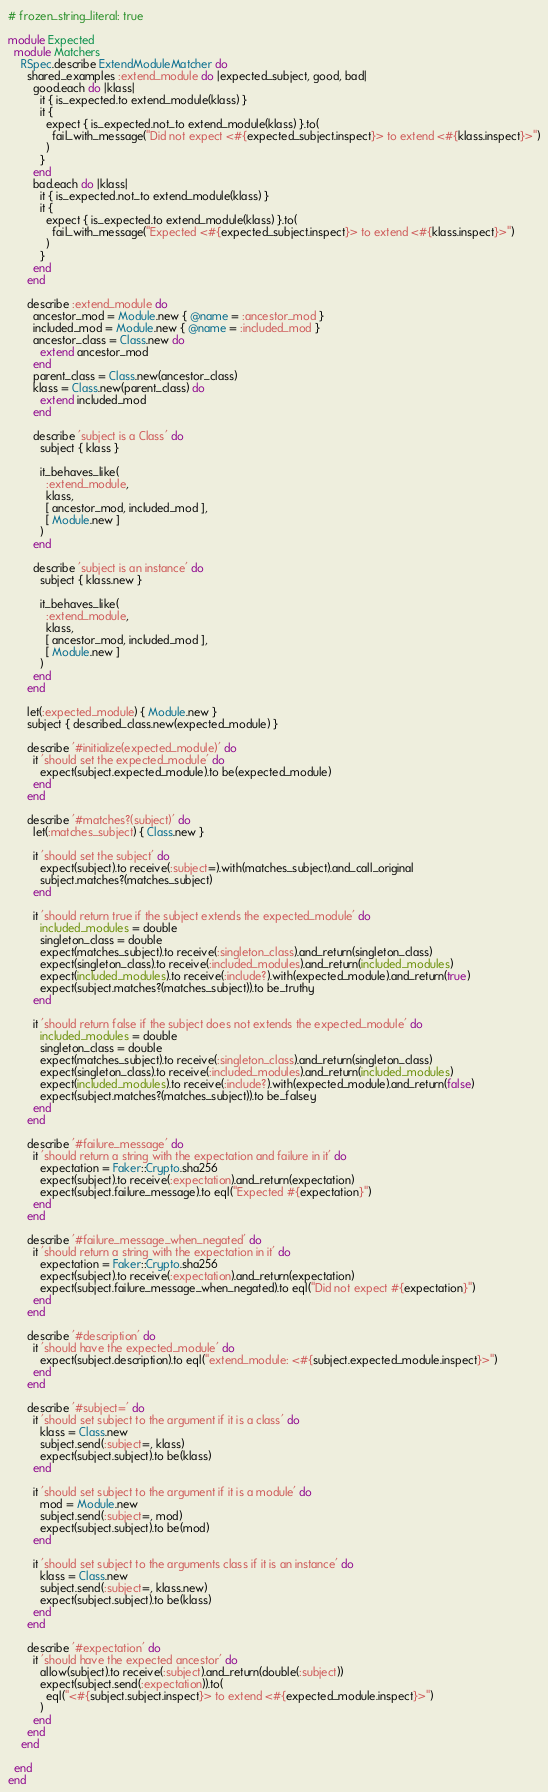<code> <loc_0><loc_0><loc_500><loc_500><_Ruby_># frozen_string_literal: true

module Expected
  module Matchers
    RSpec.describe ExtendModuleMatcher do
      shared_examples :extend_module do |expected_subject, good, bad|
        good.each do |klass|
          it { is_expected.to extend_module(klass) }
          it {
            expect { is_expected.not_to extend_module(klass) }.to(
              fail_with_message("Did not expect <#{expected_subject.inspect}> to extend <#{klass.inspect}>")
            )
          }
        end
        bad.each do |klass|
          it { is_expected.not_to extend_module(klass) }
          it {
            expect { is_expected.to extend_module(klass) }.to(
              fail_with_message("Expected <#{expected_subject.inspect}> to extend <#{klass.inspect}>")
            )
          }
        end
      end

      describe :extend_module do
        ancestor_mod = Module.new { @name = :ancestor_mod }
        included_mod = Module.new { @name = :included_mod }
        ancestor_class = Class.new do
          extend ancestor_mod
        end
        parent_class = Class.new(ancestor_class)
        klass = Class.new(parent_class) do
          extend included_mod
        end

        describe 'subject is a Class' do
          subject { klass }

          it_behaves_like(
            :extend_module,
            klass,
            [ ancestor_mod, included_mod ],
            [ Module.new ]
          )
        end

        describe 'subject is an instance' do
          subject { klass.new }

          it_behaves_like(
            :extend_module,
            klass,
            [ ancestor_mod, included_mod ],
            [ Module.new ]
          )
        end
      end

      let(:expected_module) { Module.new }
      subject { described_class.new(expected_module) }

      describe '#initialize(expected_module)' do
        it 'should set the expected_module' do
          expect(subject.expected_module).to be(expected_module)
        end
      end

      describe '#matches?(subject)' do
        let(:matches_subject) { Class.new }

        it 'should set the subject' do
          expect(subject).to receive(:subject=).with(matches_subject).and_call_original
          subject.matches?(matches_subject)
        end

        it 'should return true if the subject extends the expected_module' do
          included_modules = double
          singleton_class = double
          expect(matches_subject).to receive(:singleton_class).and_return(singleton_class)
          expect(singleton_class).to receive(:included_modules).and_return(included_modules)
          expect(included_modules).to receive(:include?).with(expected_module).and_return(true)
          expect(subject.matches?(matches_subject)).to be_truthy
        end

        it 'should return false if the subject does not extends the expected_module' do
          included_modules = double
          singleton_class = double
          expect(matches_subject).to receive(:singleton_class).and_return(singleton_class)
          expect(singleton_class).to receive(:included_modules).and_return(included_modules)
          expect(included_modules).to receive(:include?).with(expected_module).and_return(false)
          expect(subject.matches?(matches_subject)).to be_falsey
        end
      end

      describe '#failure_message' do
        it 'should return a string with the expectation and failure in it' do
          expectation = Faker::Crypto.sha256
          expect(subject).to receive(:expectation).and_return(expectation)
          expect(subject.failure_message).to eql("Expected #{expectation}")
        end
      end

      describe '#failure_message_when_negated' do
        it 'should return a string with the expectation in it' do
          expectation = Faker::Crypto.sha256
          expect(subject).to receive(:expectation).and_return(expectation)
          expect(subject.failure_message_when_negated).to eql("Did not expect #{expectation}")
        end
      end

      describe '#description' do
        it 'should have the expected_module' do
          expect(subject.description).to eql("extend_module: <#{subject.expected_module.inspect}>")
        end
      end

      describe '#subject=' do
        it 'should set subject to the argument if it is a class' do
          klass = Class.new
          subject.send(:subject=, klass)
          expect(subject.subject).to be(klass)
        end

        it 'should set subject to the argument if it is a module' do
          mod = Module.new
          subject.send(:subject=, mod)
          expect(subject.subject).to be(mod)
        end

        it 'should set subject to the arguments class if it is an instance' do
          klass = Class.new
          subject.send(:subject=, klass.new)
          expect(subject.subject).to be(klass)
        end
      end

      describe '#expectation' do
        it 'should have the expected ancestor' do
          allow(subject).to receive(:subject).and_return(double(:subject))
          expect(subject.send(:expectation)).to(
            eql("<#{subject.subject.inspect}> to extend <#{expected_module.inspect}>")
          )
        end
      end
    end

  end
end
</code> 